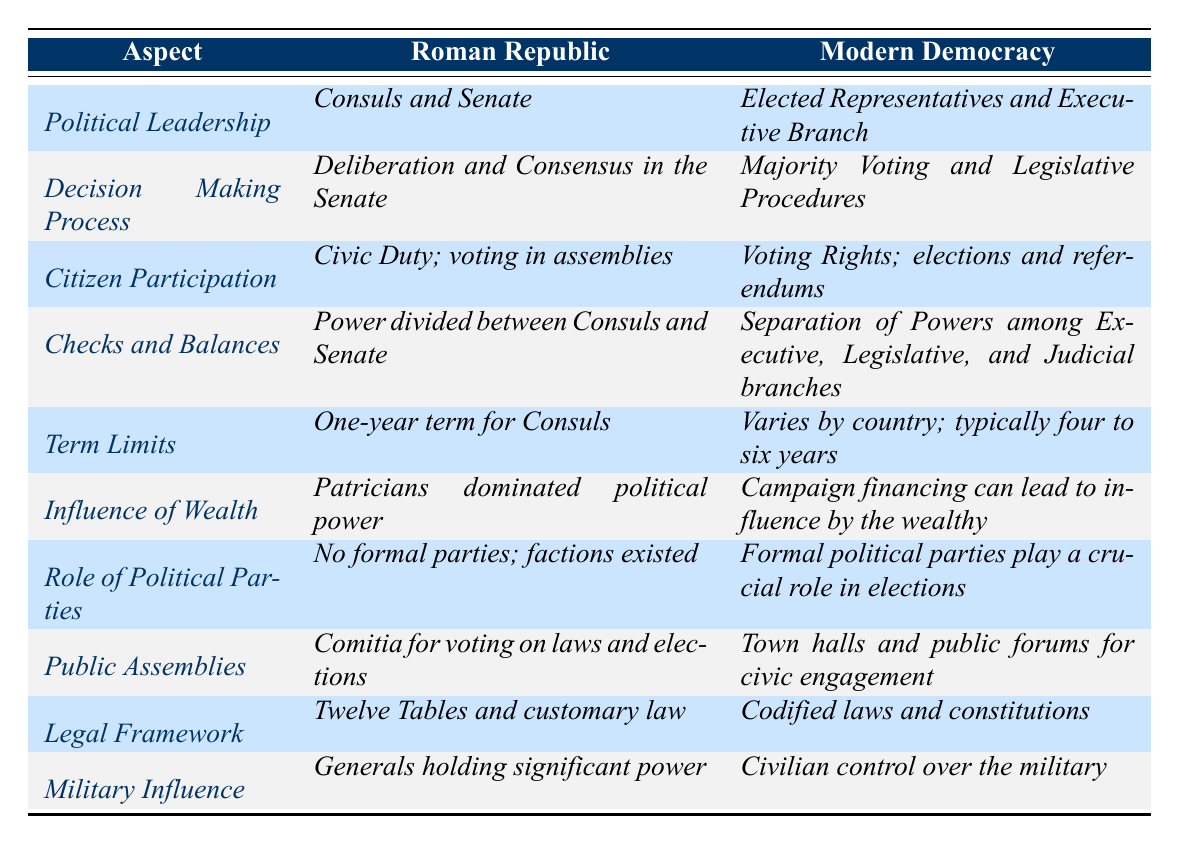What is the term limit for Consuls in the Roman Republic? The table states that the term limit for Consuls in the Roman Republic is one year according to the "Term Limits" aspect.
Answer: One year What is the political leadership structure of modern democracies? The relevant row in the table specifies that modern democracies have elected representatives and an executive branch under the "Political Leadership" aspect.
Answer: Elected Representatives and Executive Branch Is the influence of political parties present in the Roman Republic? The data indicates that there were no formal political parties in the Roman Republic, as stated in the "Role of Political Parties" aspect.
Answer: No How does the decision-making process differ between the Roman Republic and modern democracies? The table shows that the Roman Republic relied on deliberation and consensus in the Senate, while modern democracies use majority voting and legislative procedures for decision-making.
Answer: Deliberation in Senate vs. Majority Voting Which aspect indicates that wealth influences politics in both systems? In the "Influence of Wealth" row, it states that in the Roman Republic, Patricians dominated political power, and in modern democracies, campaign financing can lead to influence by the wealthy.
Answer: Wealth influences politics in both What are the key differences in citizen participation between the Roman Republic and modern democracies? The table illustrates that citizen participation in the Roman Republic involved civic duty and voting in assemblies, whereas in modern democracies, it includes voting rights along with elections and referendums.
Answer: Civic duty vs. Voting rights What does the aspect of "Checks and Balances" suggest about the power structures? The "Checks and Balances" row reveals that power in the Roman Republic was divided between Consuls and the Senate, while in modern democracies, there is a separation of powers among the executive, legislative, and judicial branches.
Answer: Division in Republic vs. Separation in democracies In terms of legal frameworks, how do the two systems compare? The "Legal Framework" aspect details that the Roman Republic followed the Twelve Tables and customary law, while modern democracies operate under codified laws and constitutions.
Answer: Customary law vs. Codified laws How many aspects discussed show military influence in politics? The table reveals that military influence is referred to in a single aspect, specifically detailing that generals held significant power in the Roman Republic, compared to modern democracies having civilian control.
Answer: One aspect Which system enables public engagement more robustly according to the table? The "Public Assemblies" aspect indicates that the Roman Republic used Comitia for voting on laws and elections, while modern democracies utilize town halls and public forums for civic engagement.
Answer: Modern democracies enable more robust engagement What are the implications of term limits in modern democracies compared to the Roman Republic? The table notes that the Roman Republic had a one-year term for Consuls, while modern democracies have variable terms, typically four to six years. This reflects a longer period for representatives in democracies.
Answer: Longer terms in democracies 